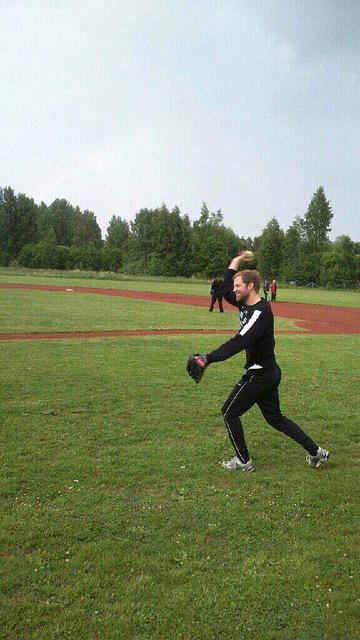What sport are this people playing?
Be succinct. Baseball. Are the man's pants tight?
Give a very brief answer. Yes. How do you see a fence?
Concise answer only. No. What color is the glove?
Give a very brief answer. Black. What is the man standing on?
Quick response, please. Grass. 